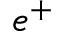<formula> <loc_0><loc_0><loc_500><loc_500>e ^ { + }</formula> 